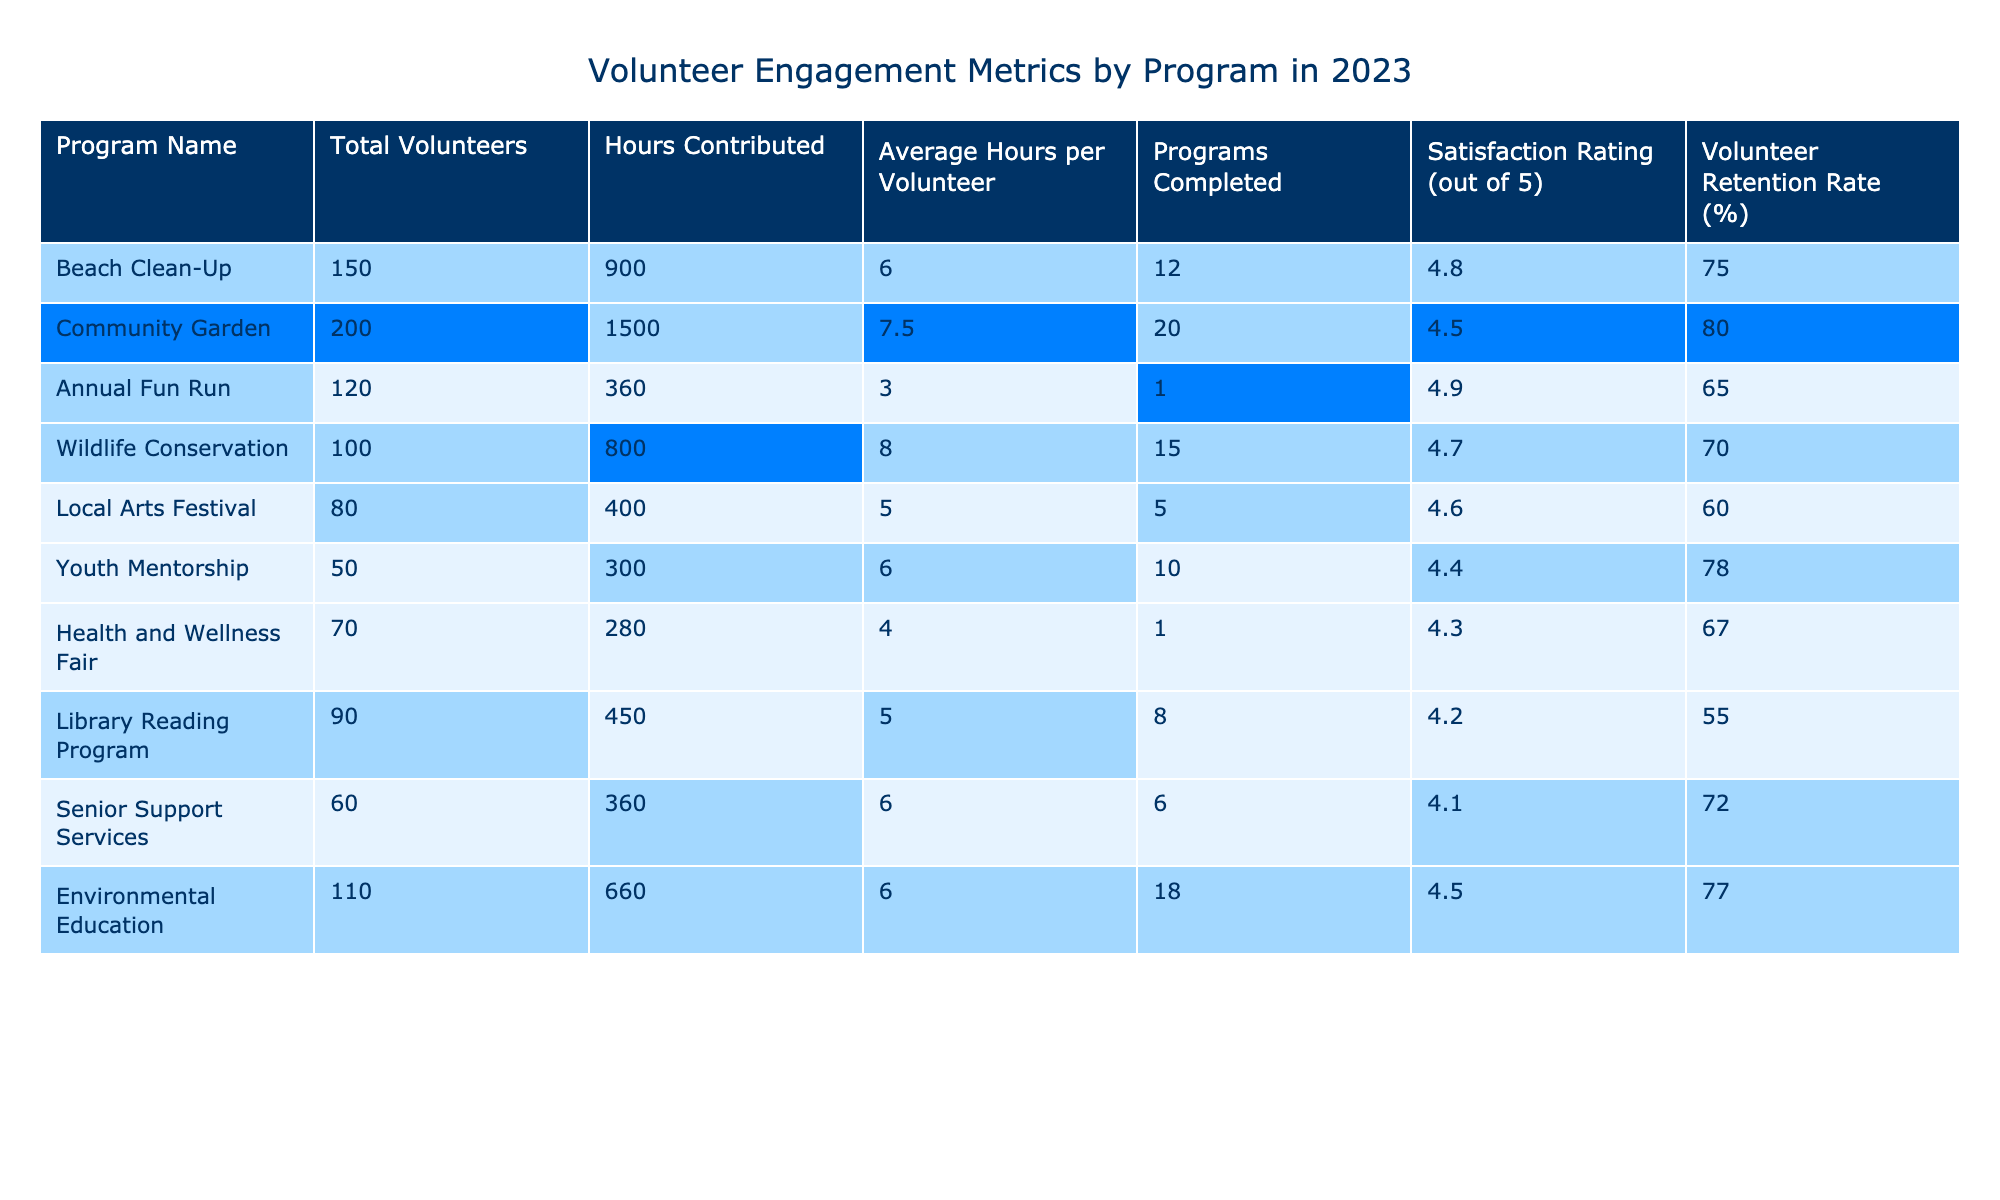What is the total number of hours contributed by volunteers in the Community Garden program? In the table, the Community Garden program has a value of 1500 hours under the "Hours Contributed" column.
Answer: 1500 Which program has the highest average hours per volunteer? By inspecting the "Average Hours per Volunteer" column, the Wildlife Conservation program shows the highest value at 8 hours.
Answer: Wildlife Conservation How many programs were completed in total across all programs? The total can be found by summing the "Programs Completed" column: (12 + 20 + 1 + 15 + 5 + 10 + 1 + 8 + 6 + 18) = 96.
Answer: 96 What is the satisfaction rating of the Local Arts Festival program? The satisfaction rating for the Local Arts Festival is found in the "Satisfaction Rating" column and is 4.6 out of 5.
Answer: 4.6 Which program has the lowest volunteer retention rate? Reviewing the "Volunteer Retention Rate" column, the Library Reading Program has the lowest rate at 55%.
Answer: Library Reading Program How many more volunteers were involved in the Beach Clean-Up compared to the Youth Mentorship program? The Beach Clean-Up program has 150 volunteers and the Youth Mentorship program has 50 volunteers. The difference is 150 - 50 = 100 volunteers.
Answer: 100 Is the average satisfaction rating across all programs above 4.5? To find the average, sum all satisfaction ratings (4.8 + 4.5 + 4.9 + 4.7 + 4.6 + 4.4 + 4.3 + 4.2 + 4.1 + 4.5 = 45) and divide by 10, resulting in an average of 4.5. Since 4.5 is not above 4.5, the answer is no.
Answer: No Which program contributed the least total hours? Looking at the "Hours Contributed" column, the Annual Fun Run program contributed only 360 hours, which is the least.
Answer: Annual Fun Run How does the volunteer retention rate of the Environmental Education program compare to the Beach Clean-Up program? The Environmental Education program has a retention rate of 77% and the Beach Clean-Up has a rate of 75%. Since 77% is greater than 75%, the Environmental Education program has a higher rate.
Answer: Higher What is the average hours contributed per volunteer for the Senior Support Services program? The table states that Senior Support Services has 360 total hours contributed with 60 volunteers, resulting in an average of 360 / 60 = 6 hours per volunteer.
Answer: 6 